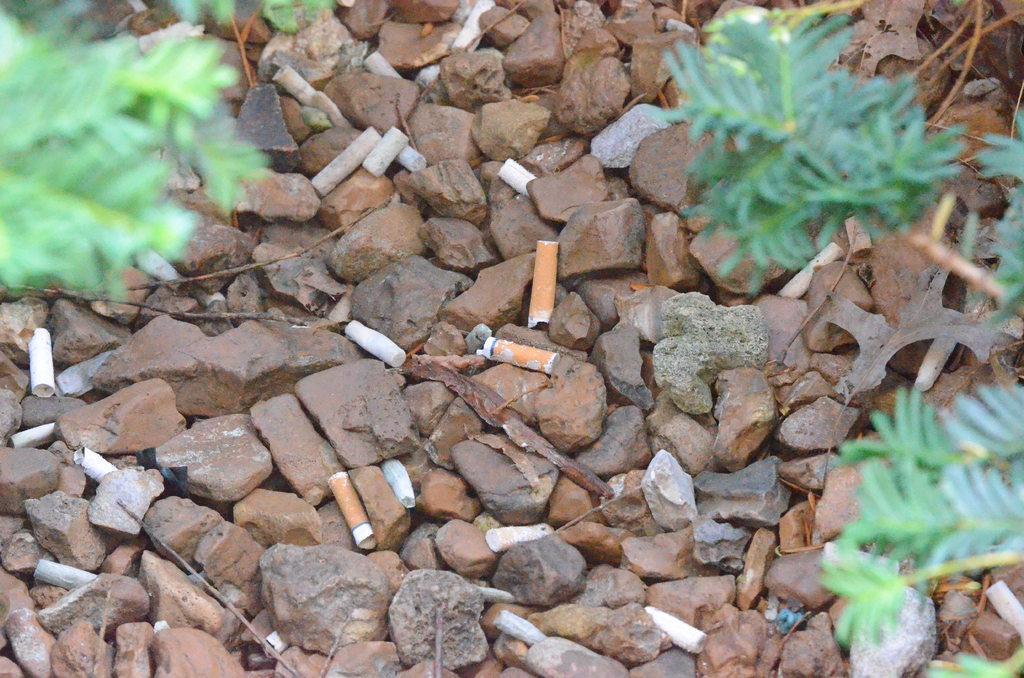Please provide a concise description of this image. In this picture we can see few stones, plants and filters of cigarettes. 